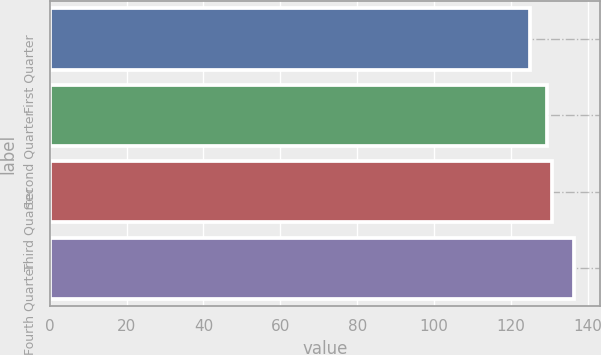<chart> <loc_0><loc_0><loc_500><loc_500><bar_chart><fcel>First Quarter<fcel>Second Quarter<fcel>Third Quarter<fcel>Fourth Quarter<nl><fcel>124.99<fcel>129.44<fcel>130.58<fcel>136.36<nl></chart> 